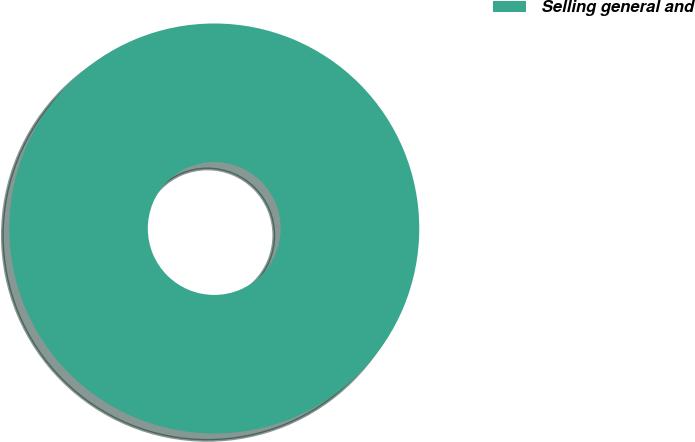Convert chart. <chart><loc_0><loc_0><loc_500><loc_500><pie_chart><fcel>Selling general and<nl><fcel>100.0%<nl></chart> 